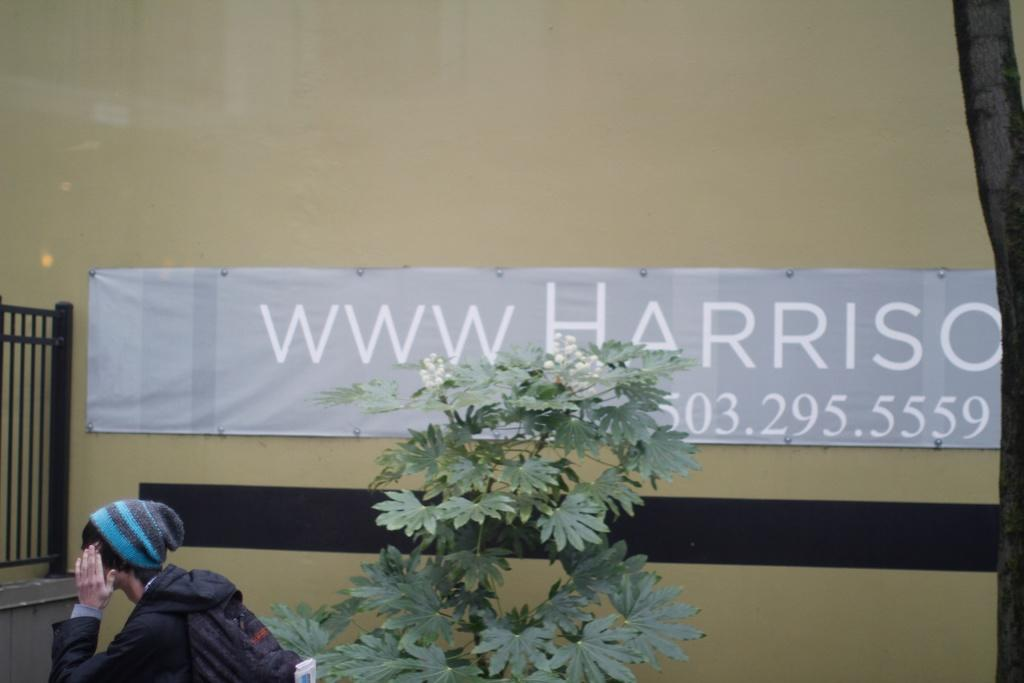Who or what is the main subject in the image? There is a person in the image. What other object is visible in the image? There is a plant in the image. What can be seen in the background of the image? There is a wall and a name board in the background of the image. Are there any other objects visible in the background? Yes, there are other objects in the background of the image. What type of angle is being used to hold the rod in the image? There is no rod present in the image, so it is not possible to determine the type of angle being used. 